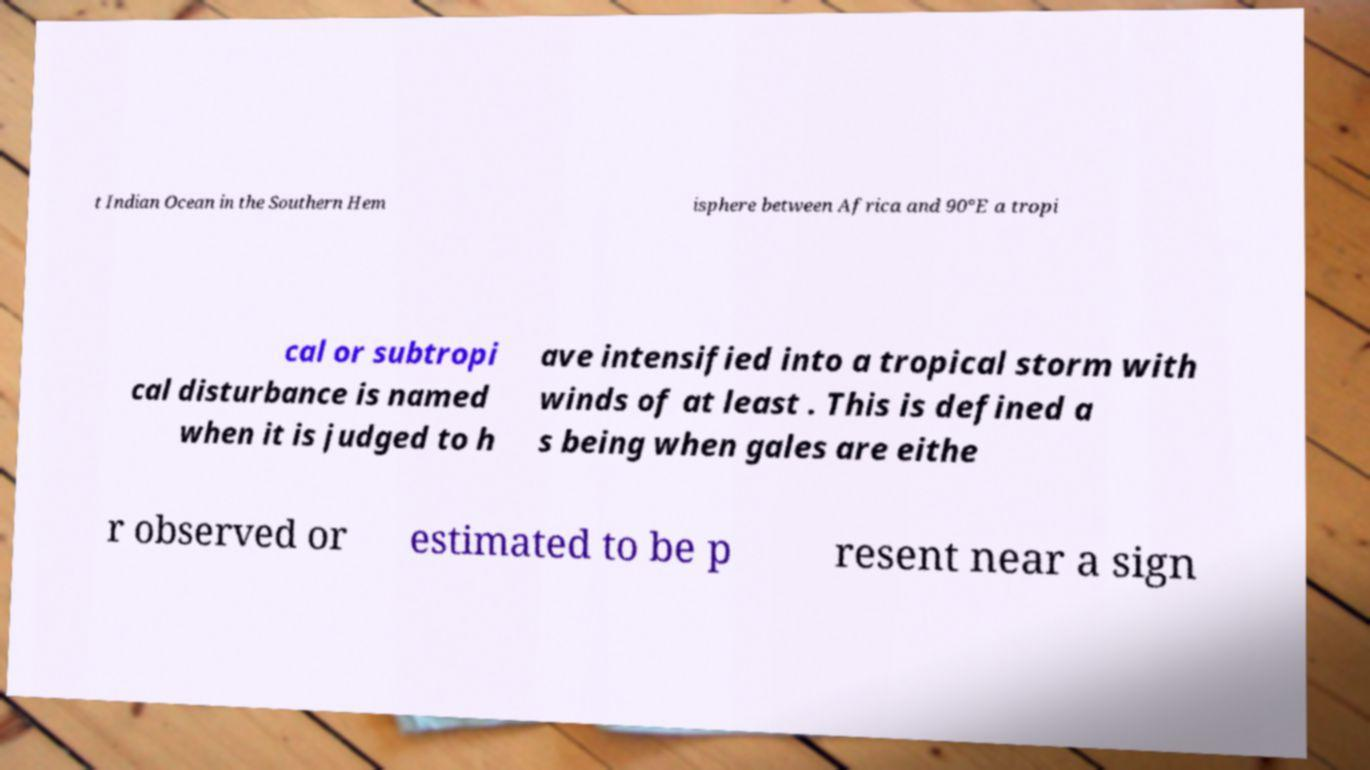There's text embedded in this image that I need extracted. Can you transcribe it verbatim? t Indian Ocean in the Southern Hem isphere between Africa and 90°E a tropi cal or subtropi cal disturbance is named when it is judged to h ave intensified into a tropical storm with winds of at least . This is defined a s being when gales are eithe r observed or estimated to be p resent near a sign 